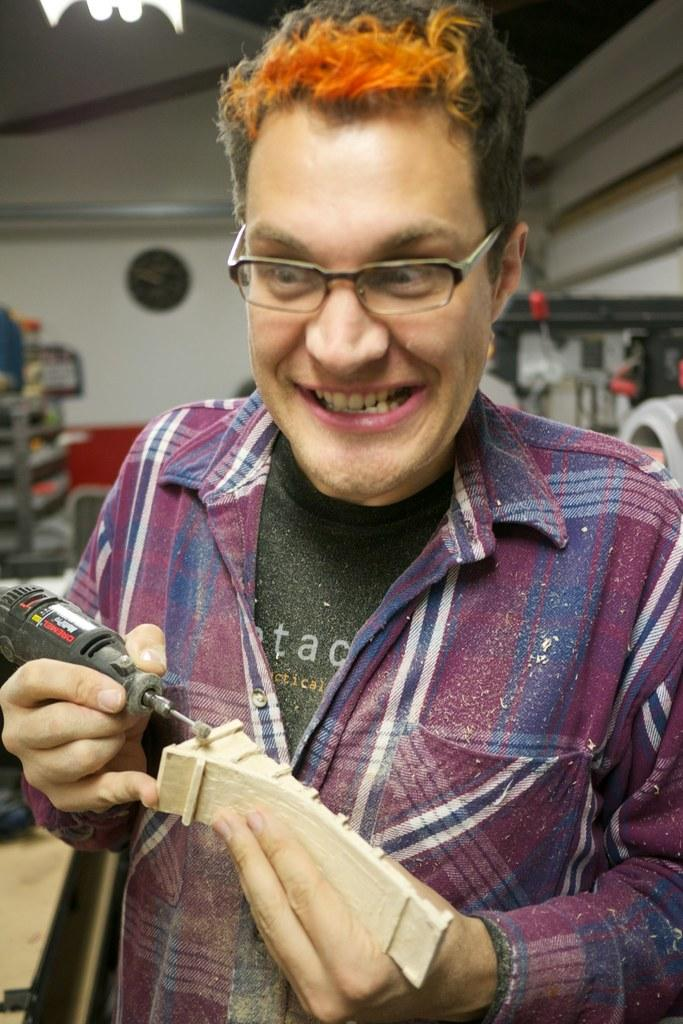What is the main subject of the image? There is a person in the image. What is the person holding in the image? The person is holding a machine and a wooden object. What can be seen in the background of the image? There are objects in the background of the image, and there is a wall. What type of joke is the person telling in the image? There is no indication of a joke being told in the image. Is there a committee meeting happening in the image? There is no information about a committee meeting in the image. 